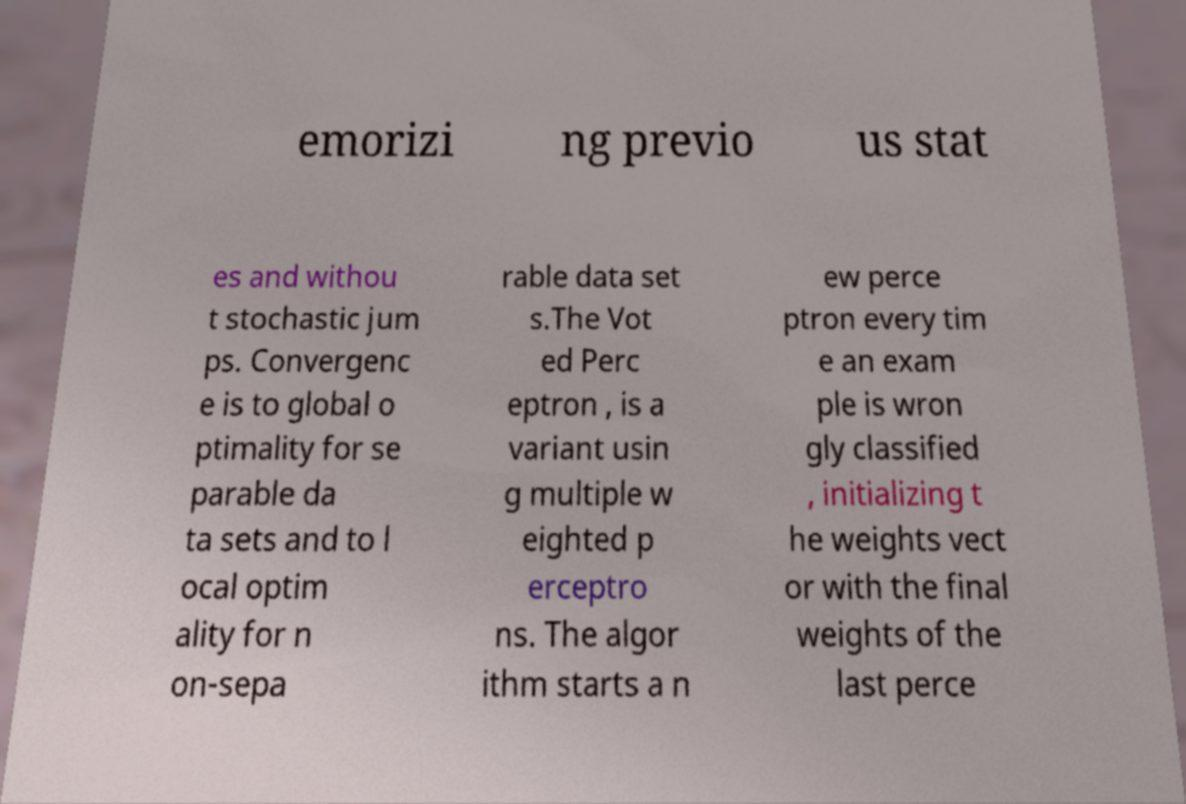There's text embedded in this image that I need extracted. Can you transcribe it verbatim? emorizi ng previo us stat es and withou t stochastic jum ps. Convergenc e is to global o ptimality for se parable da ta sets and to l ocal optim ality for n on-sepa rable data set s.The Vot ed Perc eptron , is a variant usin g multiple w eighted p erceptro ns. The algor ithm starts a n ew perce ptron every tim e an exam ple is wron gly classified , initializing t he weights vect or with the final weights of the last perce 